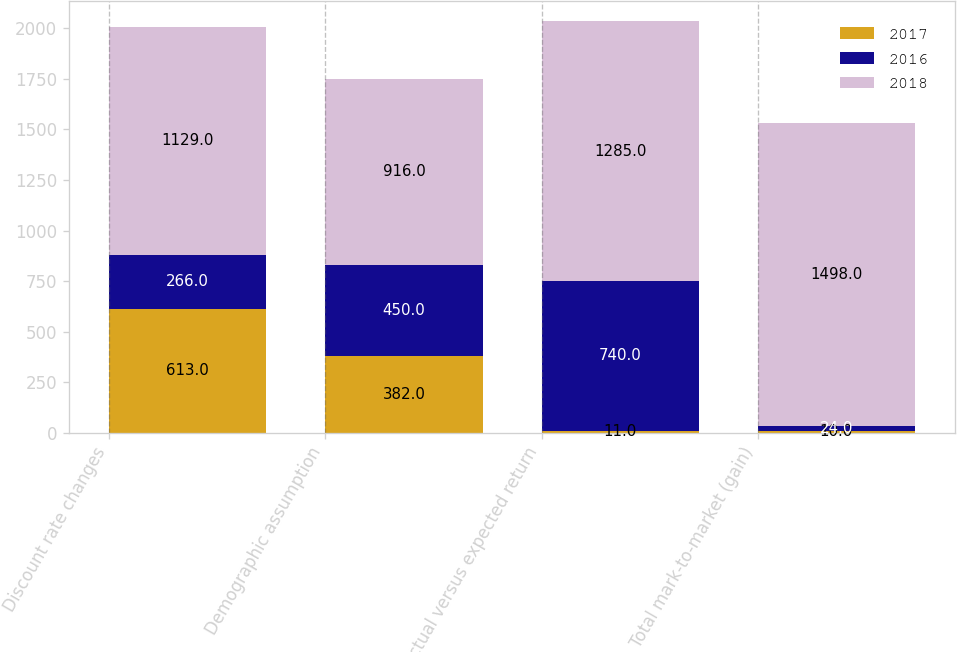Convert chart. <chart><loc_0><loc_0><loc_500><loc_500><stacked_bar_chart><ecel><fcel>Discount rate changes<fcel>Demographic assumption<fcel>Actual versus expected return<fcel>Total mark-to-market (gain)<nl><fcel>2017<fcel>613<fcel>382<fcel>11<fcel>10<nl><fcel>2016<fcel>266<fcel>450<fcel>740<fcel>24<nl><fcel>2018<fcel>1129<fcel>916<fcel>1285<fcel>1498<nl></chart> 